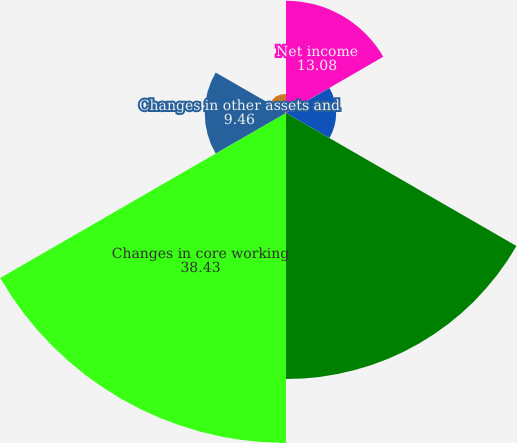Convert chart. <chart><loc_0><loc_0><loc_500><loc_500><pie_chart><fcel>Net income<fcel>Non-cash transactions 1<fcel>Postretirement benefits<fcel>Changes in core working<fcel>Changes in other assets and<fcel>Net cash provided by operating<nl><fcel>13.08%<fcel>5.84%<fcel>30.99%<fcel>38.43%<fcel>9.46%<fcel>2.21%<nl></chart> 